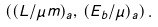<formula> <loc_0><loc_0><loc_500><loc_500>\left ( ( L / \mu m ) _ { a } , \, ( E _ { b } / \mu ) _ { a } \right ) .</formula> 